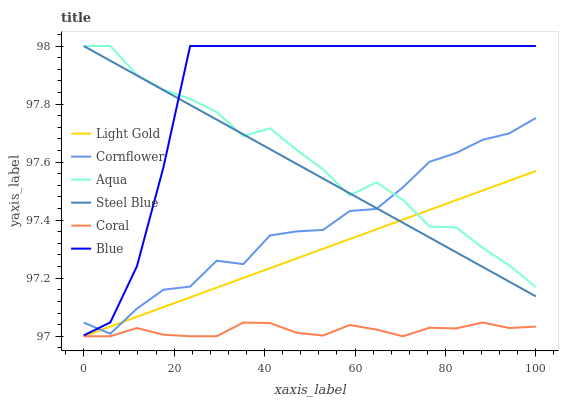Does Cornflower have the minimum area under the curve?
Answer yes or no. No. Does Cornflower have the maximum area under the curve?
Answer yes or no. No. Is Cornflower the smoothest?
Answer yes or no. No. Is Cornflower the roughest?
Answer yes or no. No. Does Cornflower have the lowest value?
Answer yes or no. No. Does Cornflower have the highest value?
Answer yes or no. No. Is Coral less than Steel Blue?
Answer yes or no. Yes. Is Blue greater than Coral?
Answer yes or no. Yes. Does Coral intersect Steel Blue?
Answer yes or no. No. 